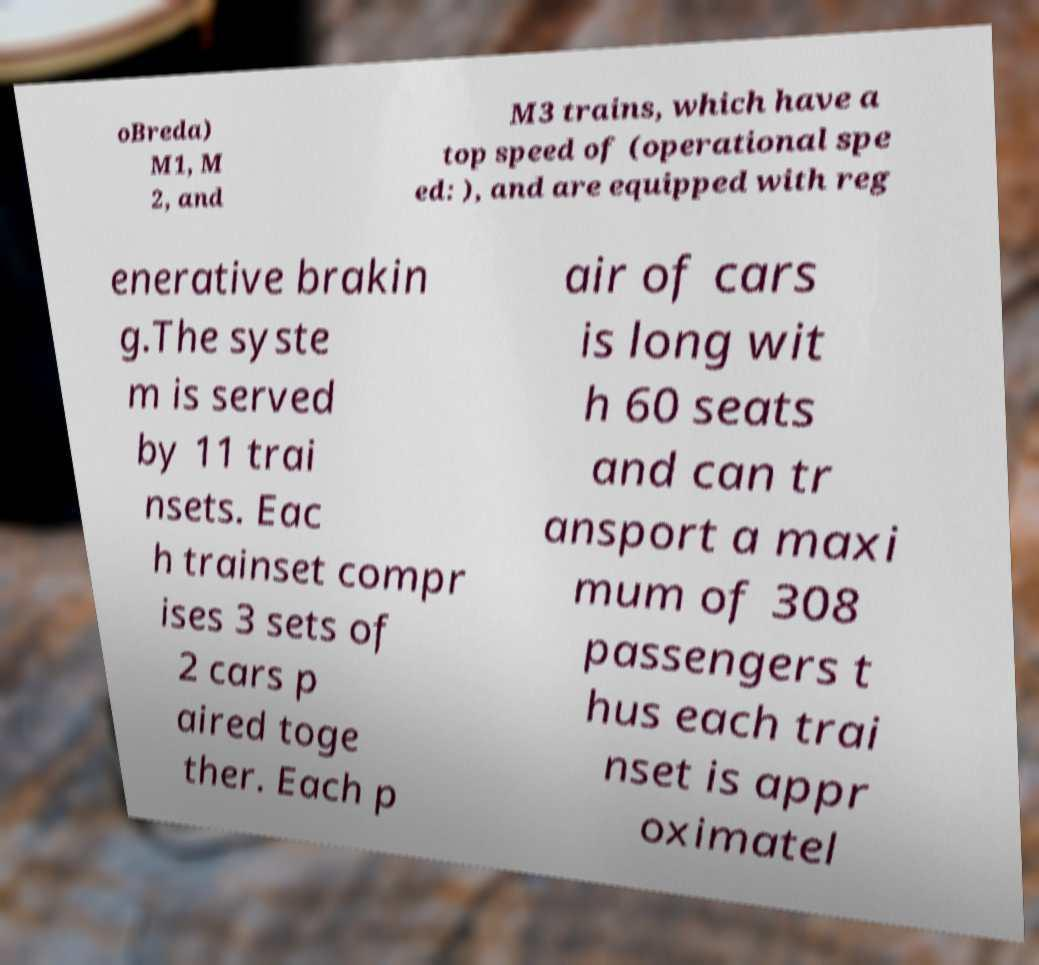Could you extract and type out the text from this image? oBreda) M1, M 2, and M3 trains, which have a top speed of (operational spe ed: ), and are equipped with reg enerative brakin g.The syste m is served by 11 trai nsets. Eac h trainset compr ises 3 sets of 2 cars p aired toge ther. Each p air of cars is long wit h 60 seats and can tr ansport a maxi mum of 308 passengers t hus each trai nset is appr oximatel 